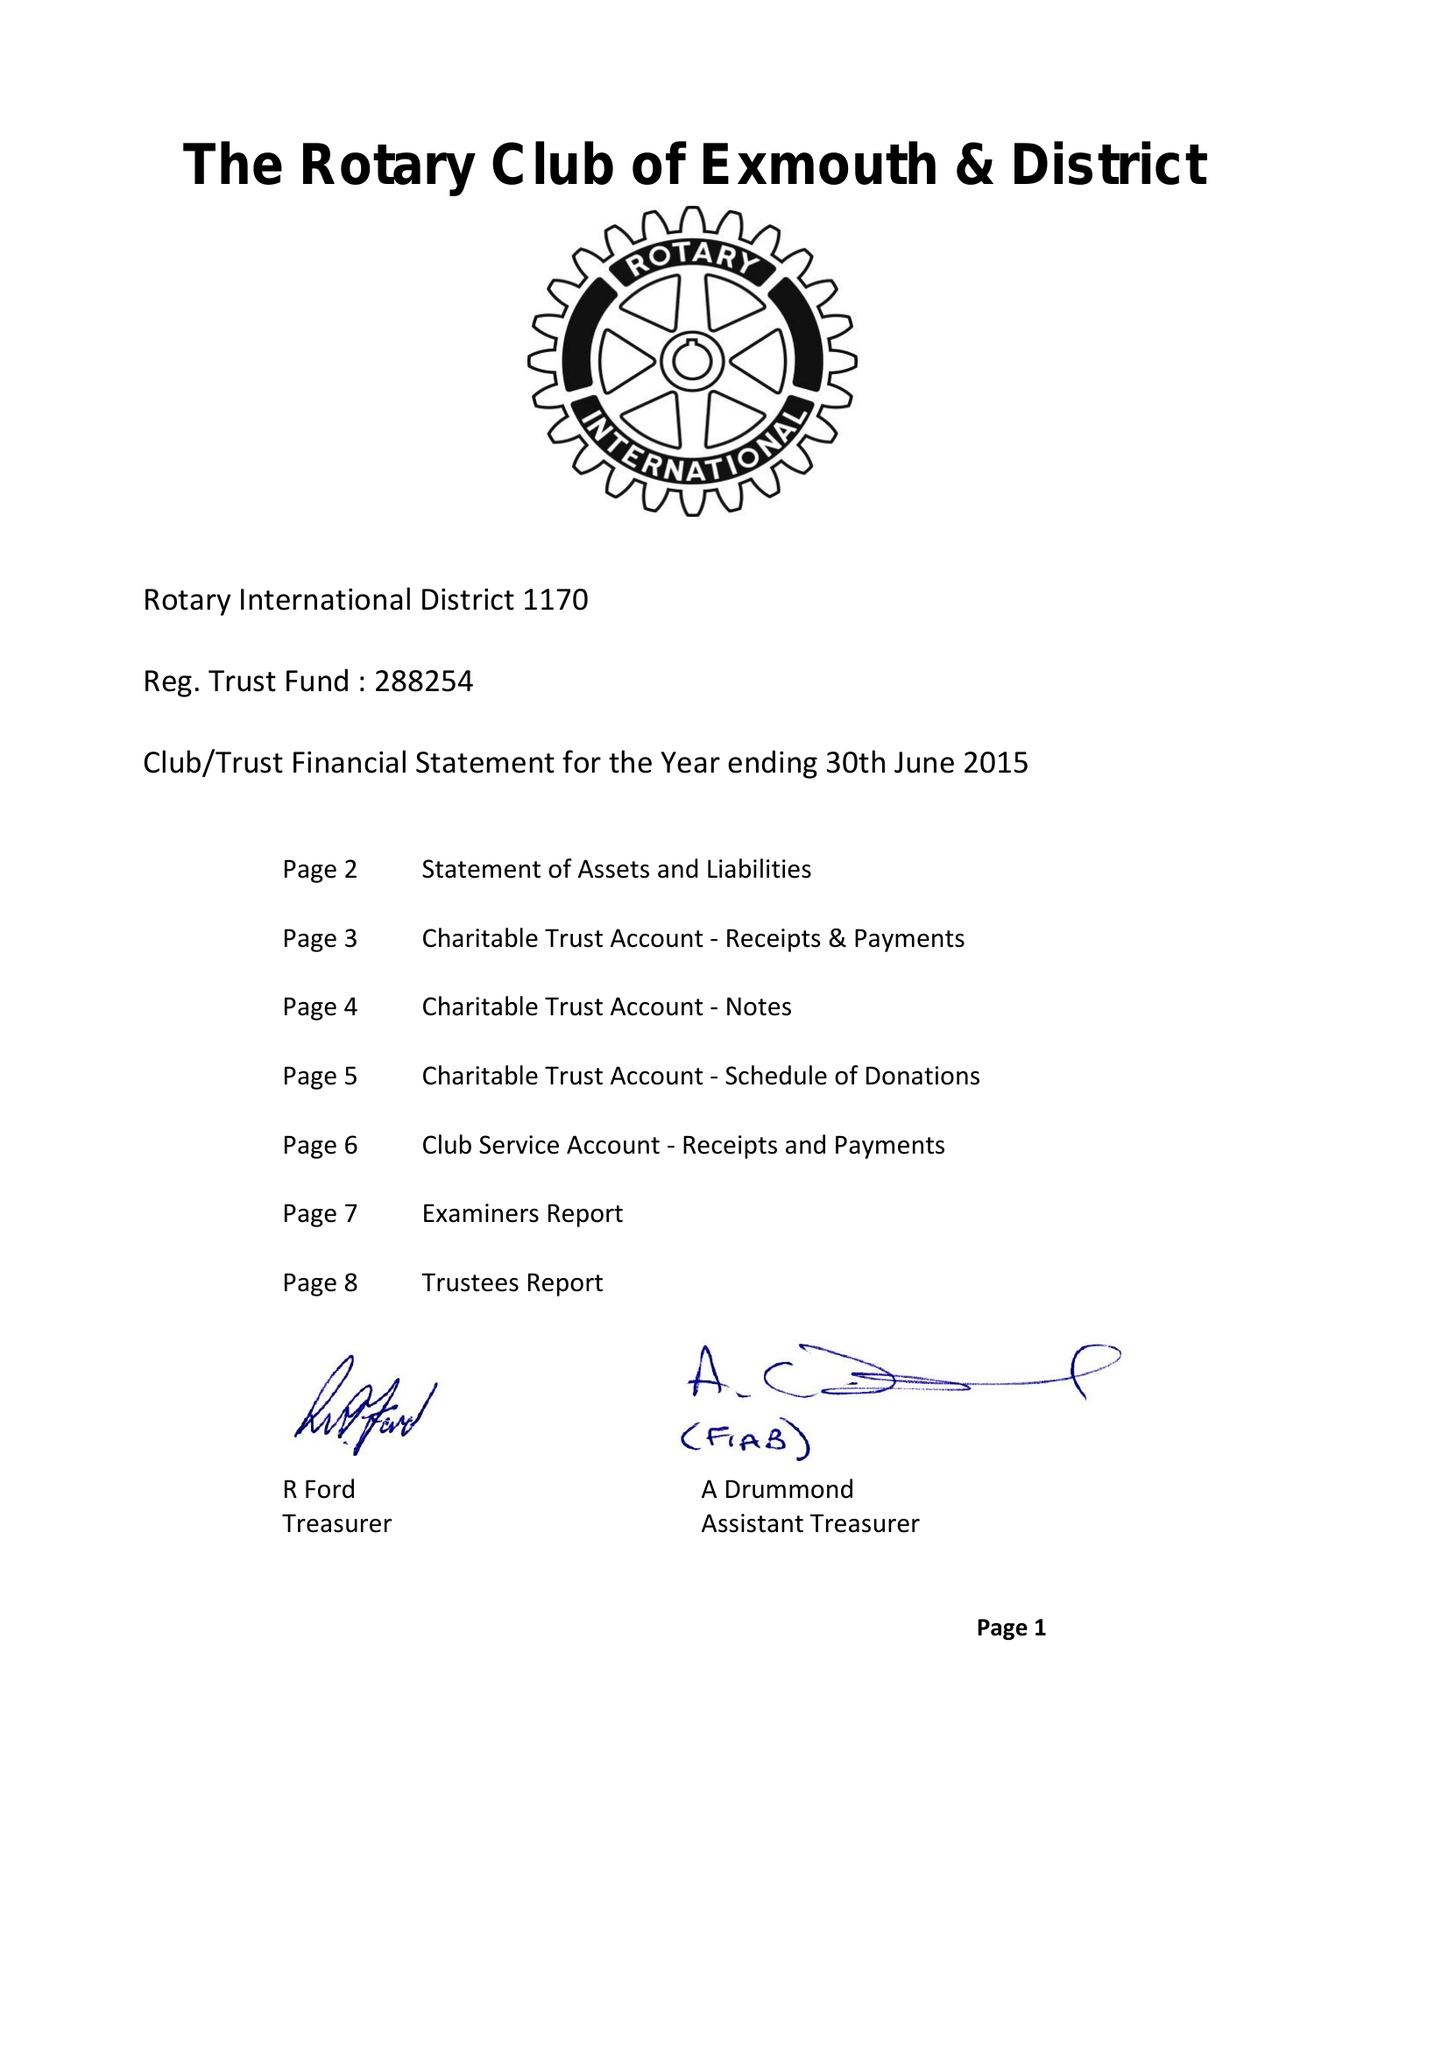What is the value for the address__post_town?
Answer the question using a single word or phrase. EXMOUTH 